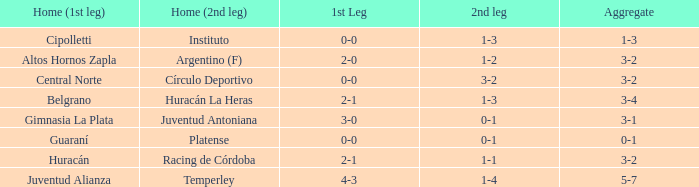What was the aggregate score that had a 1-2 second leg score? 3-2. 